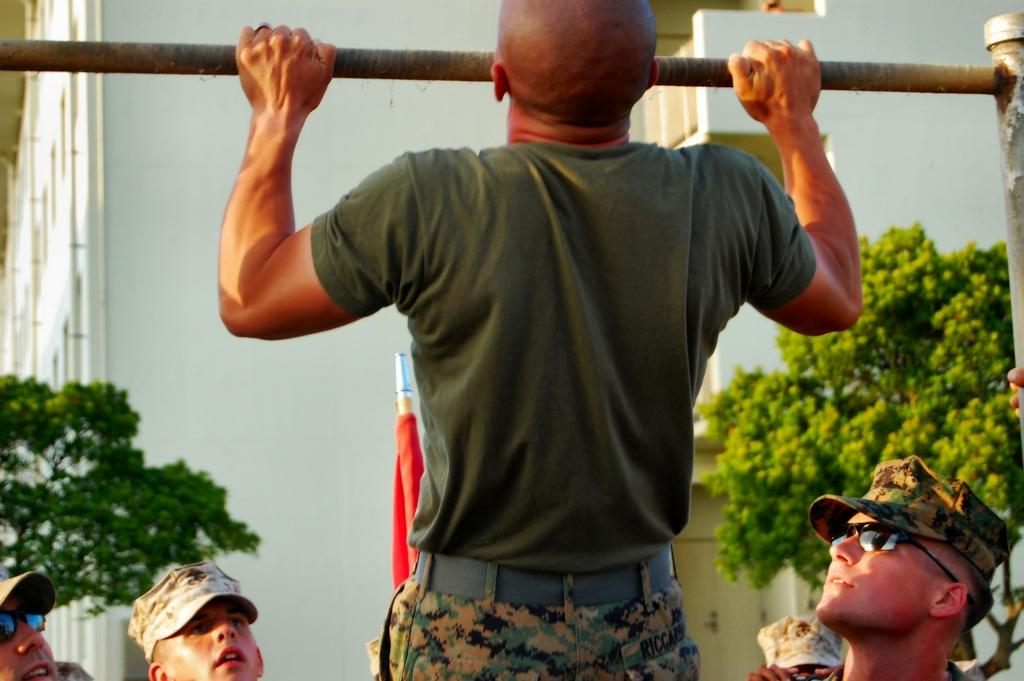What is the man in the image holding? The man is holding a metal rod in the image. What can be seen in the background of the image? There are plants and buildings visible in the background of the image. Can you describe the group of people at the bottom of the image? There is a group of people at the bottom of the image, but their specific actions or characteristics are not mentioned in the provided facts. What type of mint is growing in the bedroom in the image? There is no mention of a bedroom or mint in the image; it features a man holding a metal rod, plants, and buildings in the background. 